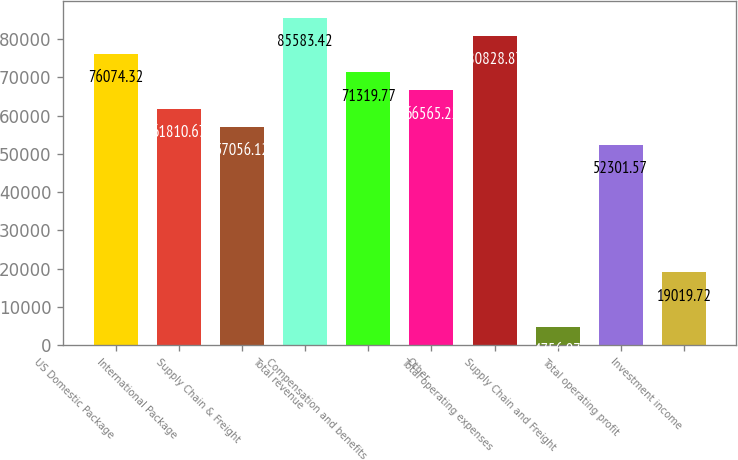<chart> <loc_0><loc_0><loc_500><loc_500><bar_chart><fcel>US Domestic Package<fcel>International Package<fcel>Supply Chain & Freight<fcel>Total revenue<fcel>Compensation and benefits<fcel>Other<fcel>Total operating expenses<fcel>Supply Chain and Freight<fcel>Total operating profit<fcel>Investment income<nl><fcel>76074.3<fcel>61810.7<fcel>57056.1<fcel>85583.4<fcel>71319.8<fcel>66565.2<fcel>80828.9<fcel>4756.07<fcel>52301.6<fcel>19019.7<nl></chart> 